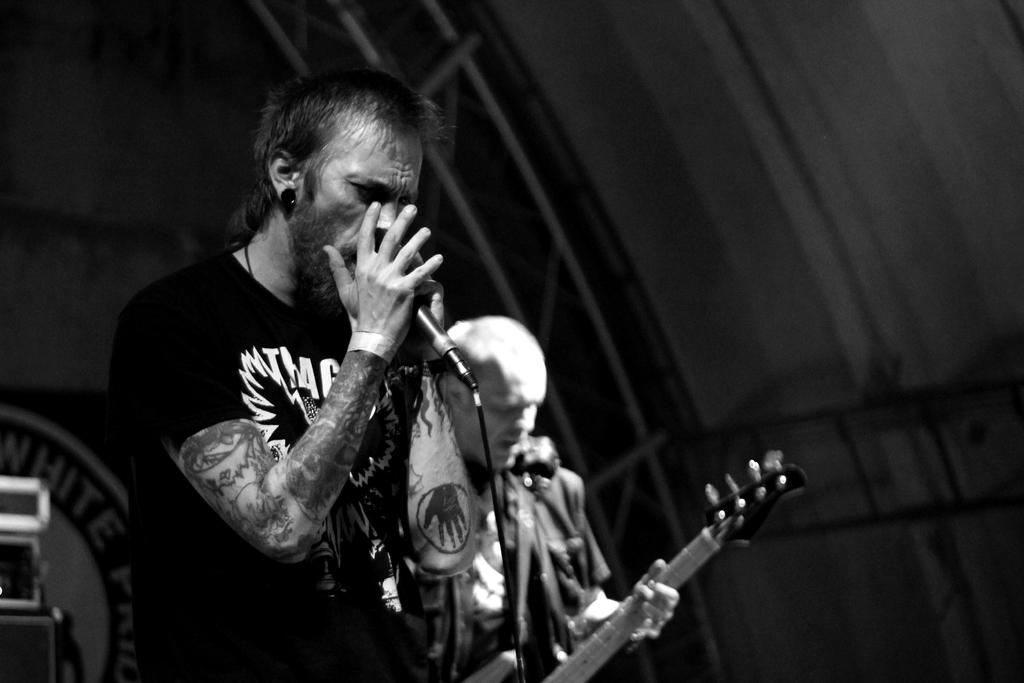What is the man in the image doing? The man is singing in the image. What is the man using while singing? The man is in front of a microphone. Who else is performing in the image? There is another person playing a guitar in the image. What can be seen behind the performers? There is a wall visible in the background of the image. What type of jelly is being served on a plate next to the guitarist? There is no jelly present in the image; it only features a man singing, a microphone, a guitarist, and a wall in the background. 